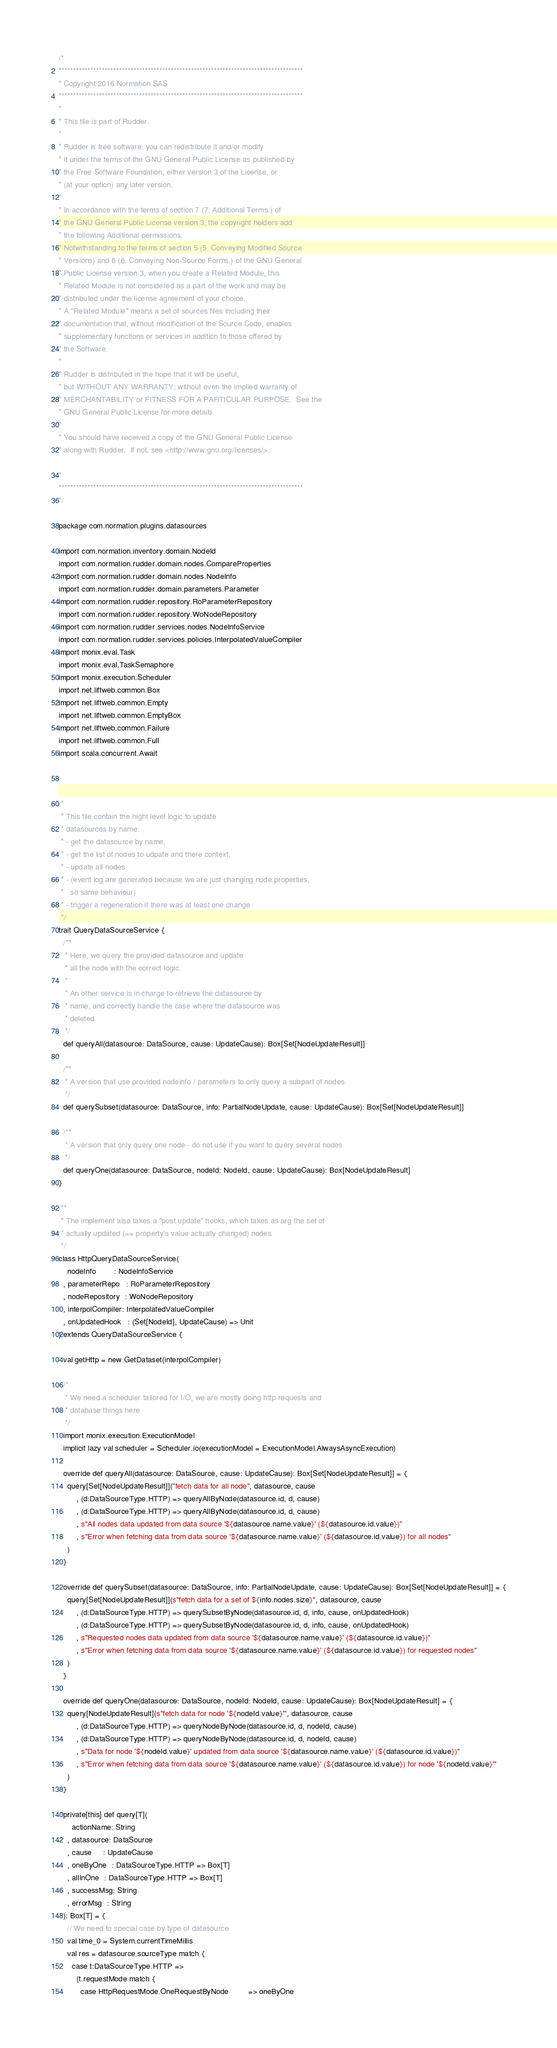<code> <loc_0><loc_0><loc_500><loc_500><_Scala_>/*
*************************************************************************************
* Copyright 2016 Normation SAS
*************************************************************************************
*
* This file is part of Rudder.
*
* Rudder is free software: you can redistribute it and/or modify
* it under the terms of the GNU General Public License as published by
* the Free Software Foundation, either version 3 of the License, or
* (at your option) any later version.
*
* In accordance with the terms of section 7 (7. Additional Terms.) of
* the GNU General Public License version 3, the copyright holders add
* the following Additional permissions:
* Notwithstanding to the terms of section 5 (5. Conveying Modified Source
* Versions) and 6 (6. Conveying Non-Source Forms.) of the GNU General
* Public License version 3, when you create a Related Module, this
* Related Module is not considered as a part of the work and may be
* distributed under the license agreement of your choice.
* A "Related Module" means a set of sources files including their
* documentation that, without modification of the Source Code, enables
* supplementary functions or services in addition to those offered by
* the Software.
*
* Rudder is distributed in the hope that it will be useful,
* but WITHOUT ANY WARRANTY; without even the implied warranty of
* MERCHANTABILITY or FITNESS FOR A PARTICULAR PURPOSE.  See the
* GNU General Public License for more details.
*
* You should have received a copy of the GNU General Public License
* along with Rudder.  If not, see <http://www.gnu.org/licenses/>.

*
*************************************************************************************
*/

package com.normation.plugins.datasources

import com.normation.inventory.domain.NodeId
import com.normation.rudder.domain.nodes.CompareProperties
import com.normation.rudder.domain.nodes.NodeInfo
import com.normation.rudder.domain.parameters.Parameter
import com.normation.rudder.repository.RoParameterRepository
import com.normation.rudder.repository.WoNodeRepository
import com.normation.rudder.services.nodes.NodeInfoService
import com.normation.rudder.services.policies.InterpolatedValueCompiler
import monix.eval.Task
import monix.eval.TaskSemaphore
import monix.execution.Scheduler
import net.liftweb.common.Box
import net.liftweb.common.Empty
import net.liftweb.common.EmptyBox
import net.liftweb.common.Failure
import net.liftweb.common.Full
import scala.concurrent.Await



/*
 * This file contain the hight level logic to update
 * datasources by name:
 * - get the datasource by name,
 * - get the list of nodes to udpate and there context,
 * - update all nodes
 * - (event log are generated because we are just changing node properties,
 *   so same behaviour)
 * - trigger a regeneration if there was at least one change
 */
trait QueryDataSourceService {
  /**
   * Here, we query the provided datasource and update
   * all the node with the correct logic.
   *
   * An other service is in charge to retrieve the datasource by
   * name, and correctly handle the case where the datasource was
   * deleted.
   */
  def queryAll(datasource: DataSource, cause: UpdateCause): Box[Set[NodeUpdateResult]]

  /**
   * A version that use provided nodeinfo / parameters to only query a subpart of nodes
   */
  def querySubset(datasource: DataSource, info: PartialNodeUpdate, cause: UpdateCause): Box[Set[NodeUpdateResult]]

  /**
   * A version that only query one node - do not use if you want to query several nodes
   */
  def queryOne(datasource: DataSource, nodeId: NodeId, cause: UpdateCause): Box[NodeUpdateResult]
}

/**
 * The implement also takes a "post update" hooks, which takes as arg the set of
 * actually updated (== property's value actually changed) nodes
 */
class HttpQueryDataSourceService(
    nodeInfo        : NodeInfoService
  , parameterRepo   : RoParameterRepository
  , nodeRepository  : WoNodeRepository
  , interpolCompiler: InterpolatedValueCompiler
  , onUpdatedHook   : (Set[NodeId], UpdateCause) => Unit
) extends QueryDataSourceService {

  val getHttp = new GetDataset(interpolCompiler)

  /*
   * We need a scheduler tailored for I/O, we are mostly doing http requests and
   * database things here
   */
  import monix.execution.ExecutionModel
  implicit lazy val scheduler = Scheduler.io(executionModel = ExecutionModel.AlwaysAsyncExecution)

  override def queryAll(datasource: DataSource, cause: UpdateCause): Box[Set[NodeUpdateResult]] = {
    query[Set[NodeUpdateResult]]("fetch data for all node", datasource, cause
        , (d:DataSourceType.HTTP) => queryAllByNode(datasource.id, d, cause)
        , (d:DataSourceType.HTTP) => queryAllByNode(datasource.id, d, cause)
        , s"All nodes data updated from data source '${datasource.name.value}' (${datasource.id.value})"
        , s"Error when fetching data from data source '${datasource.name.value}' (${datasource.id.value}) for all nodes"
    )
  }

  override def querySubset(datasource: DataSource, info: PartialNodeUpdate, cause: UpdateCause): Box[Set[NodeUpdateResult]] = {
    query[Set[NodeUpdateResult]](s"fetch data for a set of ${info.nodes.size}", datasource, cause
        , (d:DataSourceType.HTTP) => querySubsetByNode(datasource.id, d, info, cause, onUpdatedHook)
        , (d:DataSourceType.HTTP) => querySubsetByNode(datasource.id, d, info, cause, onUpdatedHook)
        , s"Requested nodes data updated from data source '${datasource.name.value}' (${datasource.id.value})"
        , s"Error when fetching data from data source '${datasource.name.value}' (${datasource.id.value}) for requested nodes"
    )
  }

  override def queryOne(datasource: DataSource, nodeId: NodeId, cause: UpdateCause): Box[NodeUpdateResult] = {
    query[NodeUpdateResult](s"fetch data for node '${nodeId.value}'", datasource, cause
        , (d:DataSourceType.HTTP) => queryNodeByNode(datasource.id, d, nodeId, cause)
        , (d:DataSourceType.HTTP) => queryNodeByNode(datasource.id, d, nodeId, cause)
        , s"Data for node '${nodeId.value}' updated from data source '${datasource.name.value}' (${datasource.id.value})"
        , s"Error when fetching data from data source '${datasource.name.value}' (${datasource.id.value}) for node '${nodeId.value}'"
    )
  }

  private[this] def query[T](
      actionName: String
    , datasource: DataSource
    , cause     : UpdateCause
    , oneByOne  : DataSourceType.HTTP => Box[T]
    , allInOne  : DataSourceType.HTTP => Box[T]
    , successMsg: String
    , errorMsg  : String
  ): Box[T] = {
    // We need to special case by type of datasource
    val time_0 = System.currentTimeMillis
    val res = datasource.sourceType match {
      case t:DataSourceType.HTTP =>
        (t.requestMode match {
          case HttpRequestMode.OneRequestByNode         => oneByOne</code> 